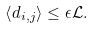<formula> <loc_0><loc_0><loc_500><loc_500>\left < d _ { i , j } \right > \leq \epsilon \mathcal { L } .</formula> 